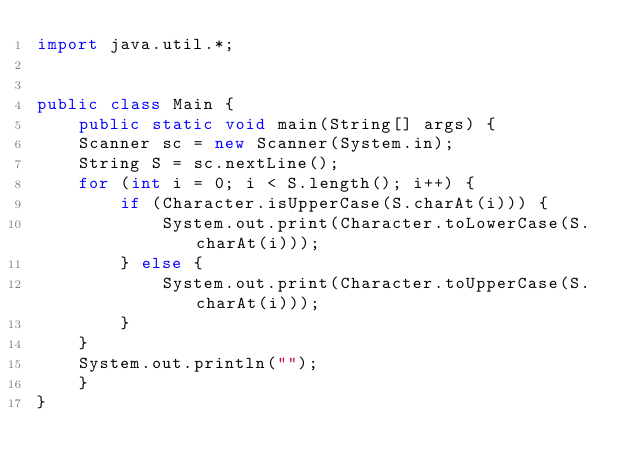<code> <loc_0><loc_0><loc_500><loc_500><_Java_>import java.util.*;


public class Main {
    public static void main(String[] args) {
		Scanner sc = new Scanner(System.in);
		String S = sc.nextLine();
		for (int i = 0; i < S.length(); i++) {
		    if (Character.isUpperCase(S.charAt(i))) {
		        System.out.print(Character.toLowerCase(S.charAt(i)));
		    } else {
		        System.out.print(Character.toUpperCase(S.charAt(i)));
		    }
		}
		System.out.println("");
    }
}
</code> 